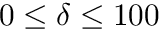Convert formula to latex. <formula><loc_0><loc_0><loc_500><loc_500>0 \leq \delta \leq 1 0 0</formula> 